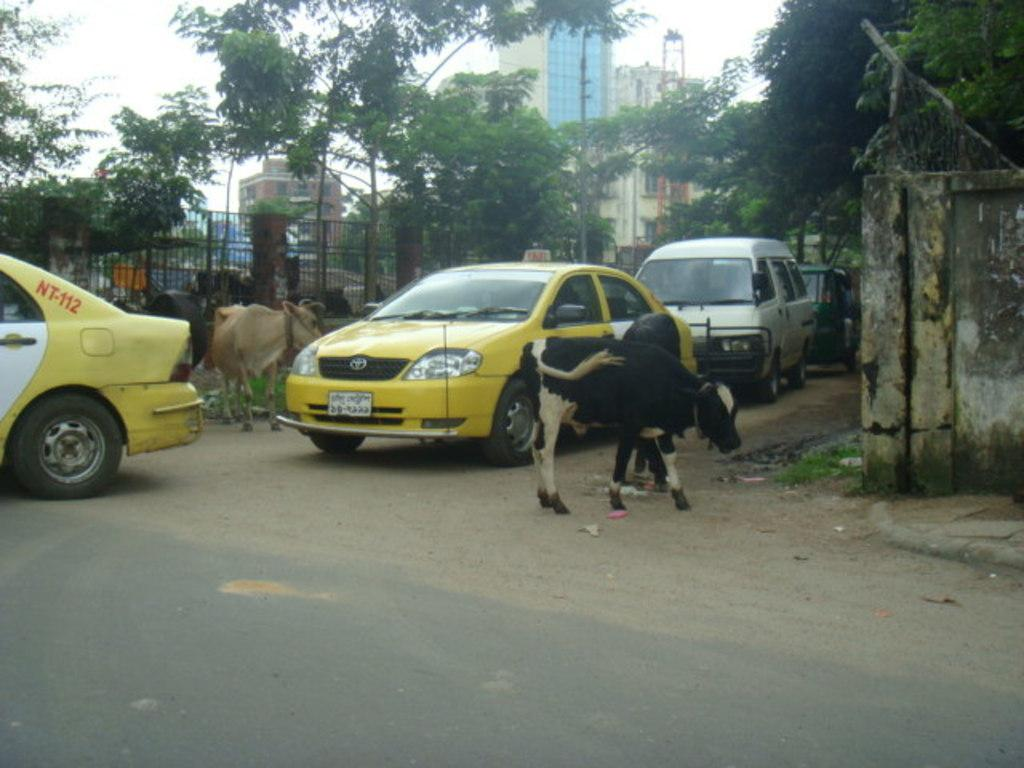<image>
Describe the image concisely. Some vehicles, one of which has NT-112 visible on it. 